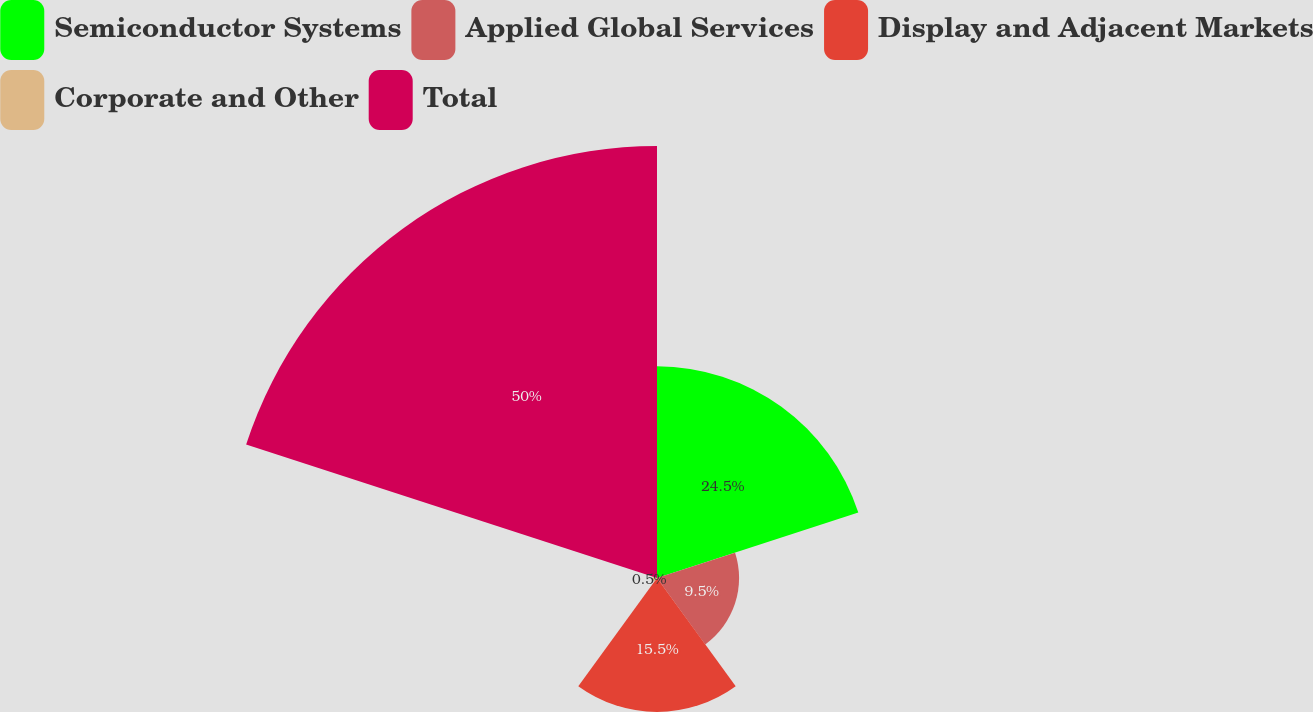Convert chart to OTSL. <chart><loc_0><loc_0><loc_500><loc_500><pie_chart><fcel>Semiconductor Systems<fcel>Applied Global Services<fcel>Display and Adjacent Markets<fcel>Corporate and Other<fcel>Total<nl><fcel>24.5%<fcel>9.5%<fcel>15.5%<fcel>0.5%<fcel>50.0%<nl></chart> 